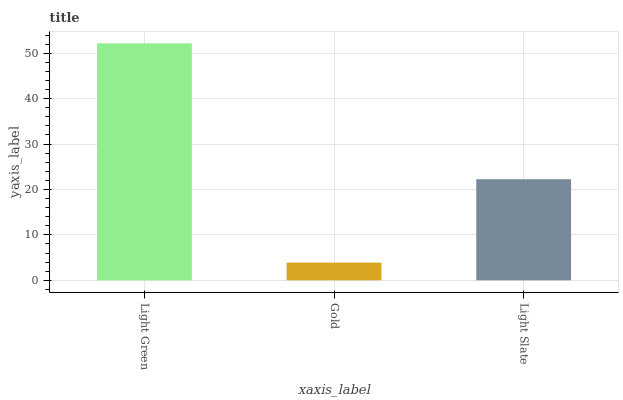Is Gold the minimum?
Answer yes or no. Yes. Is Light Green the maximum?
Answer yes or no. Yes. Is Light Slate the minimum?
Answer yes or no. No. Is Light Slate the maximum?
Answer yes or no. No. Is Light Slate greater than Gold?
Answer yes or no. Yes. Is Gold less than Light Slate?
Answer yes or no. Yes. Is Gold greater than Light Slate?
Answer yes or no. No. Is Light Slate less than Gold?
Answer yes or no. No. Is Light Slate the high median?
Answer yes or no. Yes. Is Light Slate the low median?
Answer yes or no. Yes. Is Light Green the high median?
Answer yes or no. No. Is Light Green the low median?
Answer yes or no. No. 